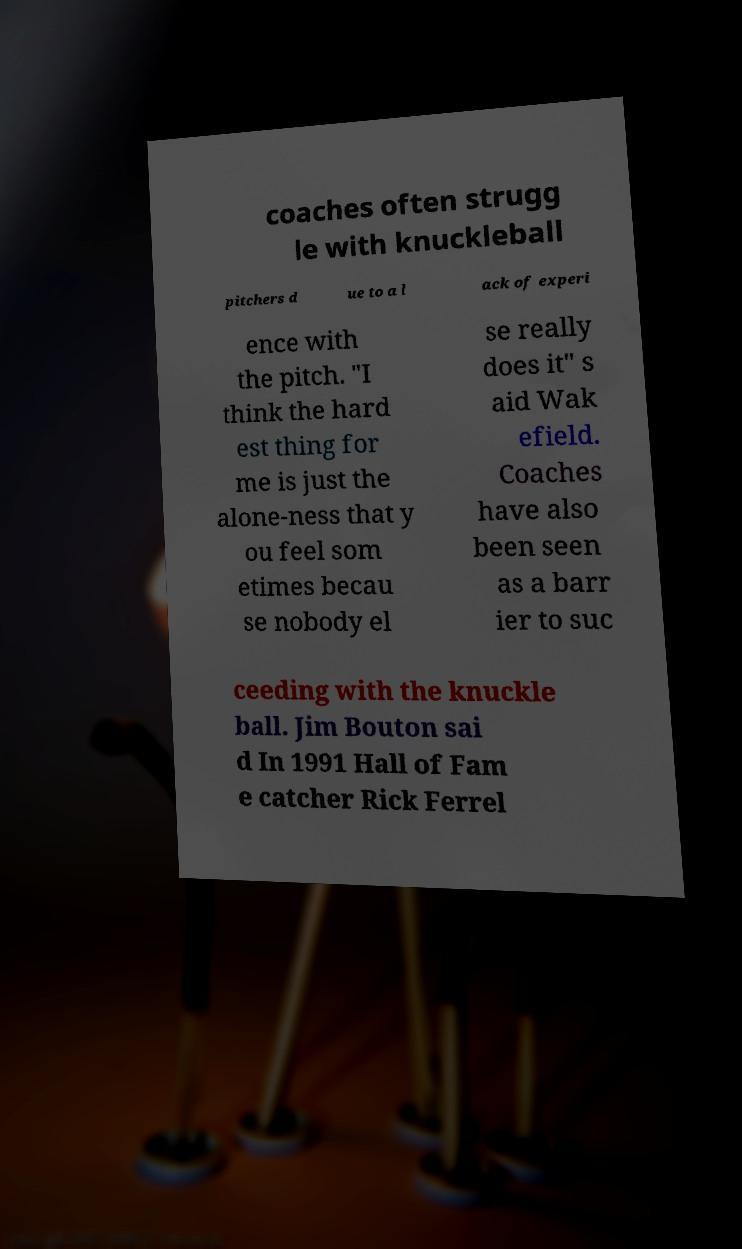Please identify and transcribe the text found in this image. coaches often strugg le with knuckleball pitchers d ue to a l ack of experi ence with the pitch. "I think the hard est thing for me is just the alone-ness that y ou feel som etimes becau se nobody el se really does it" s aid Wak efield. Coaches have also been seen as a barr ier to suc ceeding with the knuckle ball. Jim Bouton sai d In 1991 Hall of Fam e catcher Rick Ferrel 